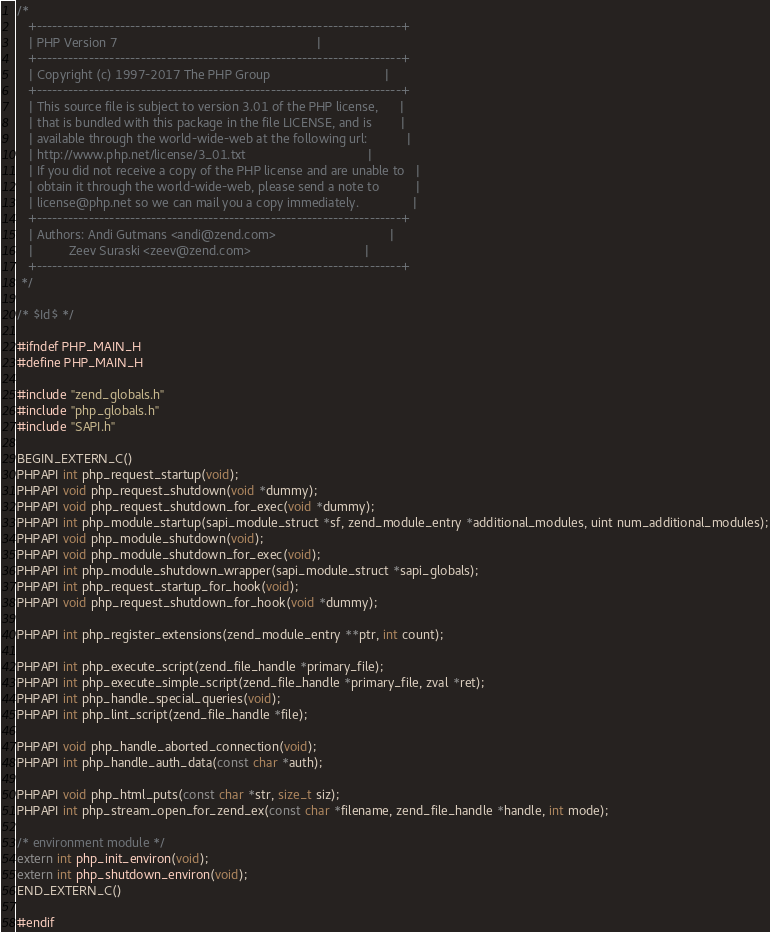Convert code to text. <code><loc_0><loc_0><loc_500><loc_500><_C_>/*
   +----------------------------------------------------------------------+
   | PHP Version 7                                                        |
   +----------------------------------------------------------------------+
   | Copyright (c) 1997-2017 The PHP Group                                |
   +----------------------------------------------------------------------+
   | This source file is subject to version 3.01 of the PHP license,      |
   | that is bundled with this package in the file LICENSE, and is        |
   | available through the world-wide-web at the following url:           |
   | http://www.php.net/license/3_01.txt                                  |
   | If you did not receive a copy of the PHP license and are unable to   |
   | obtain it through the world-wide-web, please send a note to          |
   | license@php.net so we can mail you a copy immediately.               |
   +----------------------------------------------------------------------+
   | Authors: Andi Gutmans <andi@zend.com>                                |
   |          Zeev Suraski <zeev@zend.com>                                |
   +----------------------------------------------------------------------+
 */

/* $Id$ */

#ifndef PHP_MAIN_H
#define PHP_MAIN_H

#include "zend_globals.h"
#include "php_globals.h"
#include "SAPI.h"

BEGIN_EXTERN_C()
PHPAPI int php_request_startup(void);
PHPAPI void php_request_shutdown(void *dummy);
PHPAPI void php_request_shutdown_for_exec(void *dummy);
PHPAPI int php_module_startup(sapi_module_struct *sf, zend_module_entry *additional_modules, uint num_additional_modules);
PHPAPI void php_module_shutdown(void);
PHPAPI void php_module_shutdown_for_exec(void);
PHPAPI int php_module_shutdown_wrapper(sapi_module_struct *sapi_globals);
PHPAPI int php_request_startup_for_hook(void);
PHPAPI void php_request_shutdown_for_hook(void *dummy);

PHPAPI int php_register_extensions(zend_module_entry **ptr, int count);

PHPAPI int php_execute_script(zend_file_handle *primary_file);
PHPAPI int php_execute_simple_script(zend_file_handle *primary_file, zval *ret);
PHPAPI int php_handle_special_queries(void);
PHPAPI int php_lint_script(zend_file_handle *file);

PHPAPI void php_handle_aborted_connection(void);
PHPAPI int php_handle_auth_data(const char *auth);

PHPAPI void php_html_puts(const char *str, size_t siz);
PHPAPI int php_stream_open_for_zend_ex(const char *filename, zend_file_handle *handle, int mode);

/* environment module */
extern int php_init_environ(void);
extern int php_shutdown_environ(void);
END_EXTERN_C()

#endif
</code> 